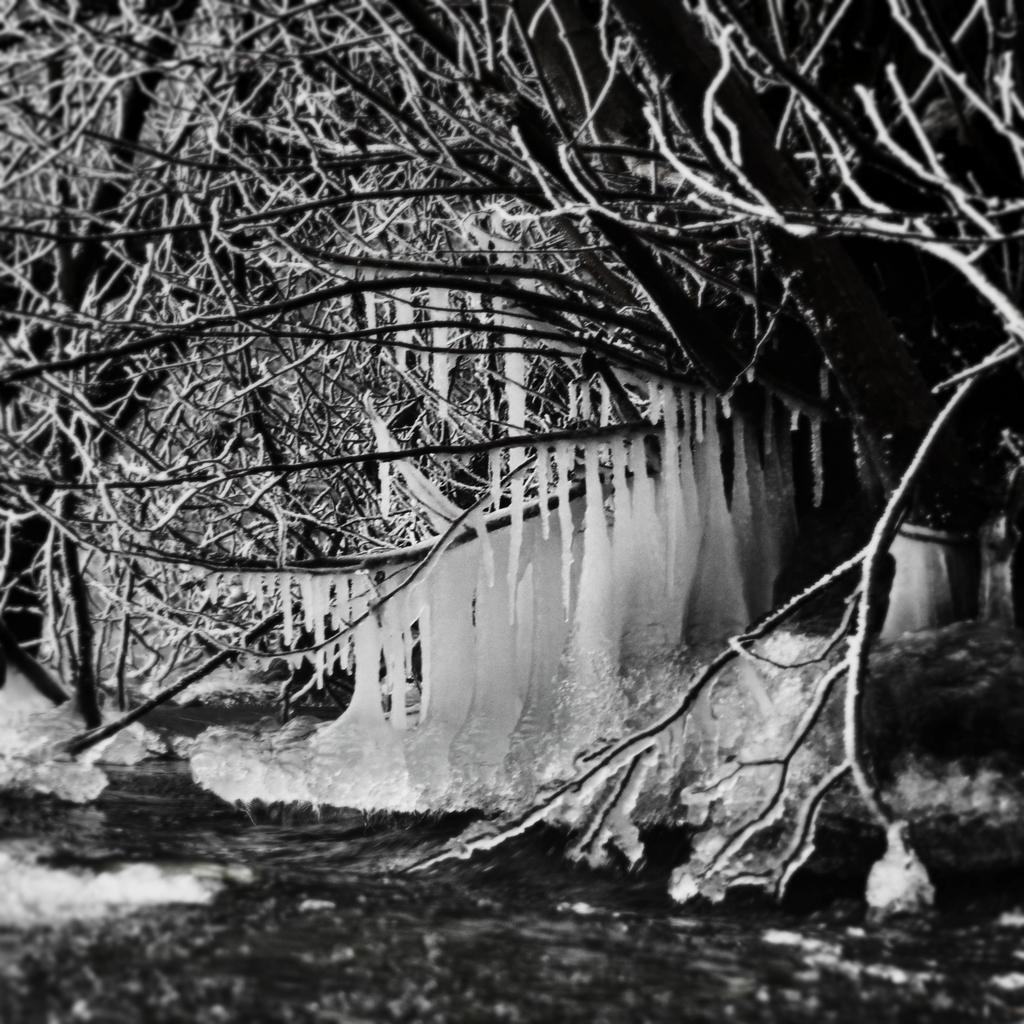What type of image is shown in the picture? The image is a negative image. What can be seen in the negative image? There is ice visible in the image. What type of natural elements are present in the image? There are trees in the image. What language is spoken by the people in the image? There are no people visible in the image, so it is not possible to determine what language they might speak. 